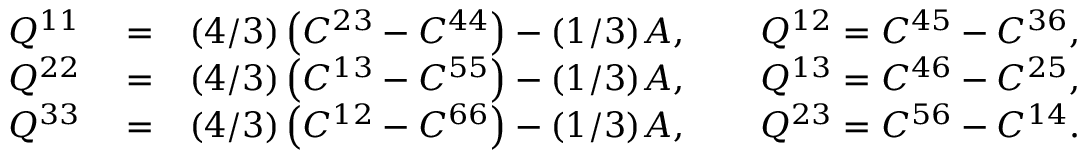<formula> <loc_0><loc_0><loc_500><loc_500>\begin{array} { r l r } { Q ^ { 1 1 } } & = } & { ( 4 / 3 ) \left ( C ^ { 2 3 } - C ^ { 4 4 } \right ) - ( 1 / 3 ) A , \quad Q ^ { 1 2 } = C ^ { 4 5 } - C ^ { 3 6 } , } \\ { Q ^ { 2 2 } } & = } & { ( 4 / 3 ) \left ( C ^ { 1 3 } - C ^ { 5 5 } \right ) - ( 1 / 3 ) A , \quad Q ^ { 1 3 } = C ^ { 4 6 } - C ^ { 2 5 } , } \\ { Q ^ { 3 3 } } & = } & { ( 4 / 3 ) \left ( C ^ { 1 2 } - C ^ { 6 6 } \right ) - ( 1 / 3 ) A , \quad Q ^ { 2 3 } = C ^ { 5 6 } - C ^ { 1 4 } . } \end{array}</formula> 